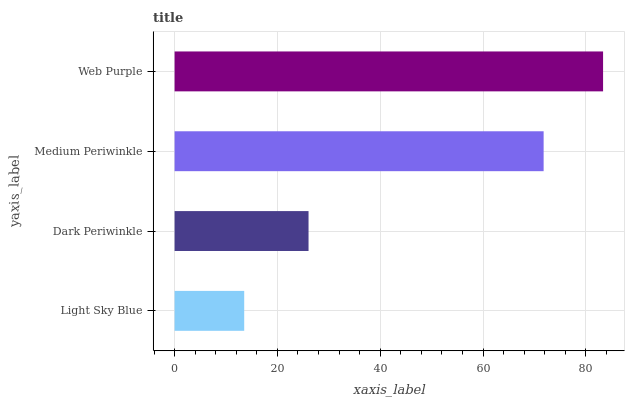Is Light Sky Blue the minimum?
Answer yes or no. Yes. Is Web Purple the maximum?
Answer yes or no. Yes. Is Dark Periwinkle the minimum?
Answer yes or no. No. Is Dark Periwinkle the maximum?
Answer yes or no. No. Is Dark Periwinkle greater than Light Sky Blue?
Answer yes or no. Yes. Is Light Sky Blue less than Dark Periwinkle?
Answer yes or no. Yes. Is Light Sky Blue greater than Dark Periwinkle?
Answer yes or no. No. Is Dark Periwinkle less than Light Sky Blue?
Answer yes or no. No. Is Medium Periwinkle the high median?
Answer yes or no. Yes. Is Dark Periwinkle the low median?
Answer yes or no. Yes. Is Dark Periwinkle the high median?
Answer yes or no. No. Is Medium Periwinkle the low median?
Answer yes or no. No. 